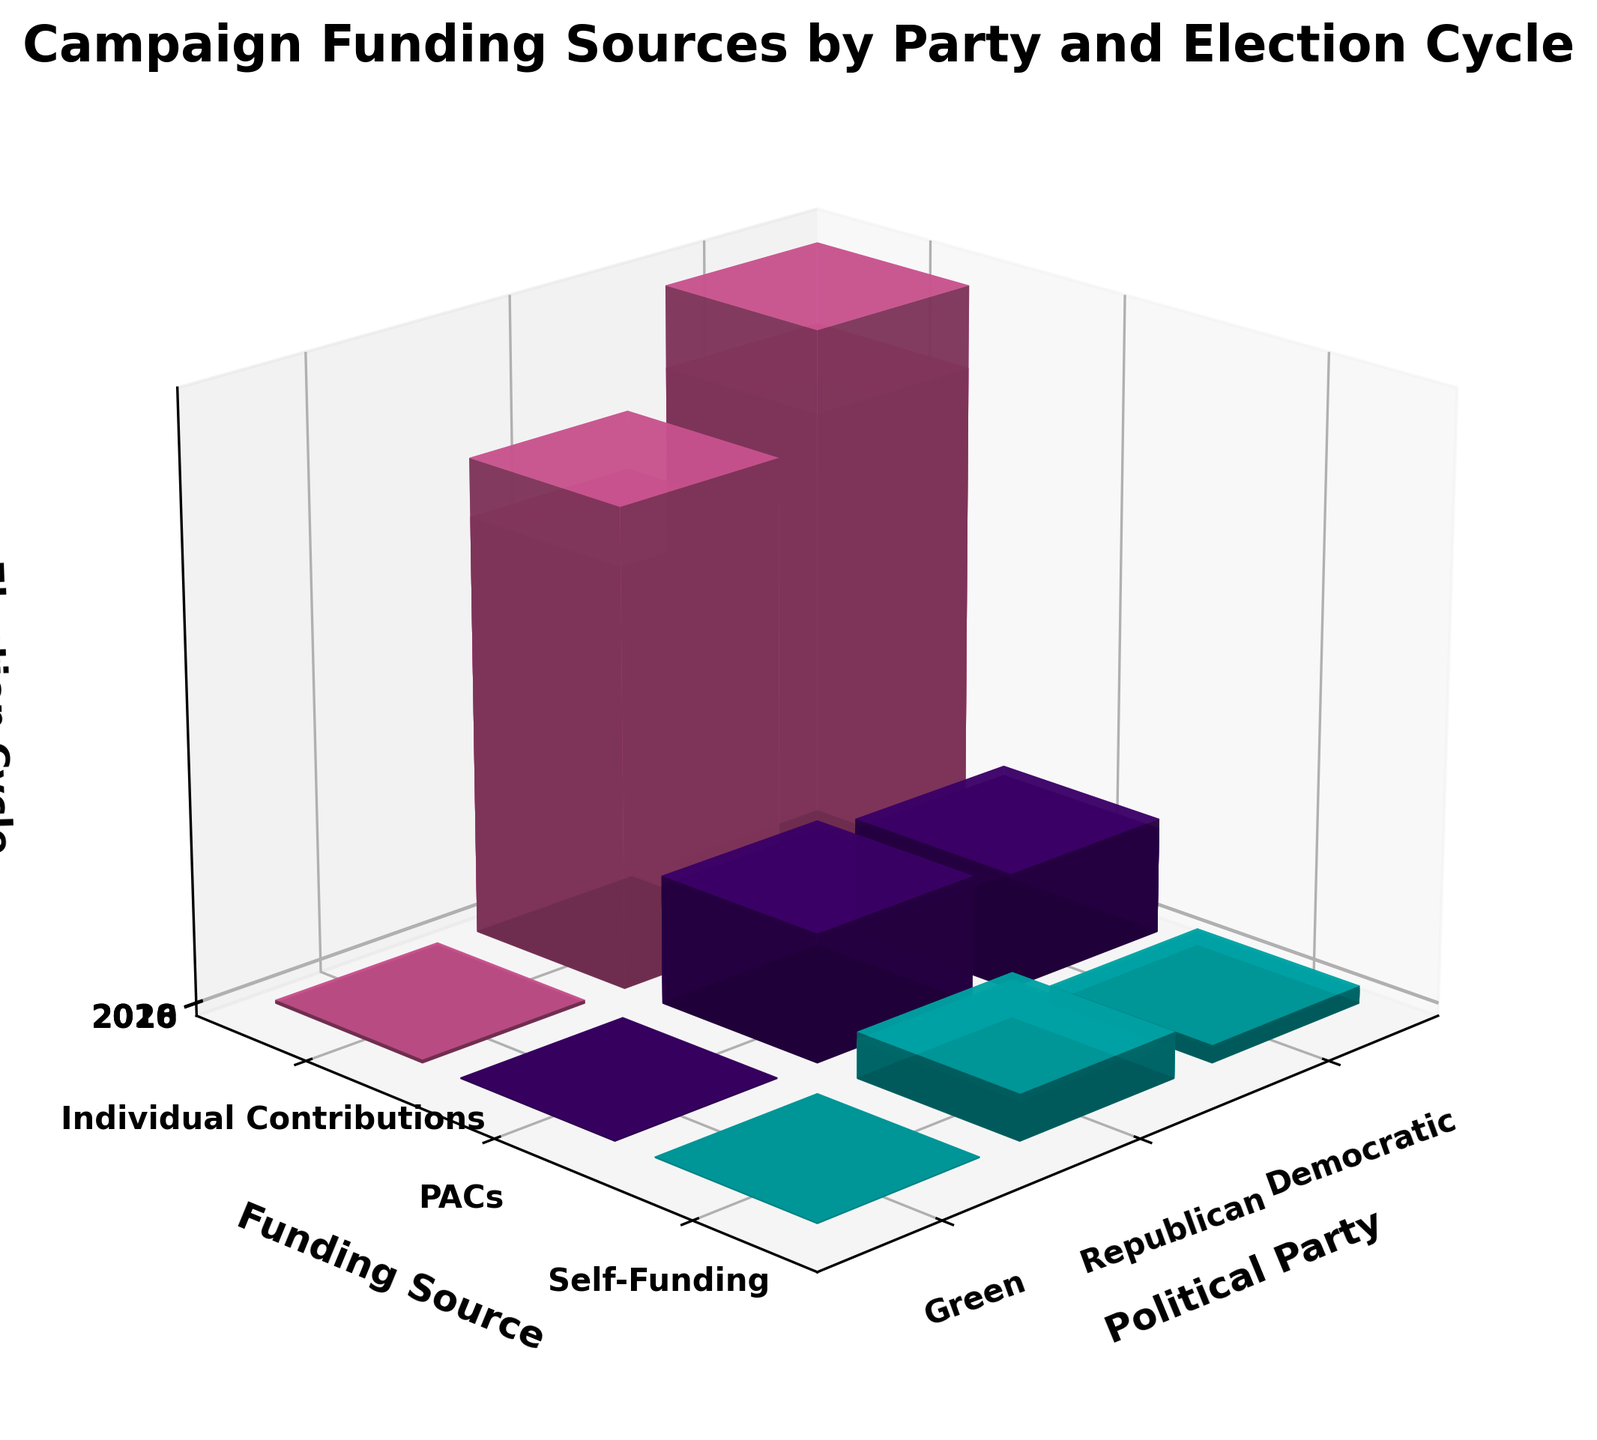What is the title of the figure? The title is usually displayed at the top of the plot. In this case, it is clearly written to describe the content of the figure.
Answer: Campaign Funding Sources by Party and Election Cycle Which political party received the highest amount from individual contributions in the 2020 election cycle? Look at the 2020 election cycle axis and compare the heights of the bars for individual contributions across all political parties. The highest bar indicates the party with the most contributions.
Answer: Democratic What is the total funding amount from PACs for the Republican party across all election cycles? Add the heights of the Republican bars from PACs in each election cycle (2016, 2018, and 2020). The amounts are 205, 221, and 238 respectively. So, 205 + 221 + 238 = 664 million.
Answer: 664 million How did the Democratic party's self-funding trend from 2016 to 2020? Look at the heights of the bars for self-funding for the Democratic party for the 2016, 2018, and 2020 election cycles. Compare the heights to see the trend.
Answer: Increasing (25 in 2016, 28 in 2018, and 32 in 2020) Which funding source showed the largest increase for the Green party from 2016 to 2020? Compare the height differences for each funding source for the Green party between 2016 and 2020. Individual Contributions increased from 3.5 to 5.1, PACs from 0.2 to 0.4, and Self-Funding from 0.1 to 0.3. The largest increase is in Individual Contributions.
Answer: Individual Contributions What is the average amount of individual contributions for all parties over the three election cycles? Sum the amounts of individual contributions for all parties across the three election cycles (848+736+3.5+952+784+4.2+1105+892+5.1) and divide by the total number of instances (9). The sum is 4330.8 and the average is 4330.8 / 9 ≈ 481 million.
Answer: 481 million Compare the funding amounts for PACs between the Democratic and Republican parties in 2020. Which party received more? Look at the height of the bars for PACs in 2020 for both the Democratic and Republican parties. The bar for the Republican party is taller.
Answer: Republican Which election cycle had the highest self-funding for the Republican party? Compare the heights of the bars for self-funding for the Republican party across the 2016, 2018, and 2020 election cycles. The highest bar represents the 2020 cycle.
Answer: 2020 